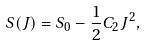Convert formula to latex. <formula><loc_0><loc_0><loc_500><loc_500>S ( J ) = S _ { 0 } - \frac { 1 } { 2 } C _ { 2 } J ^ { 2 } ,</formula> 